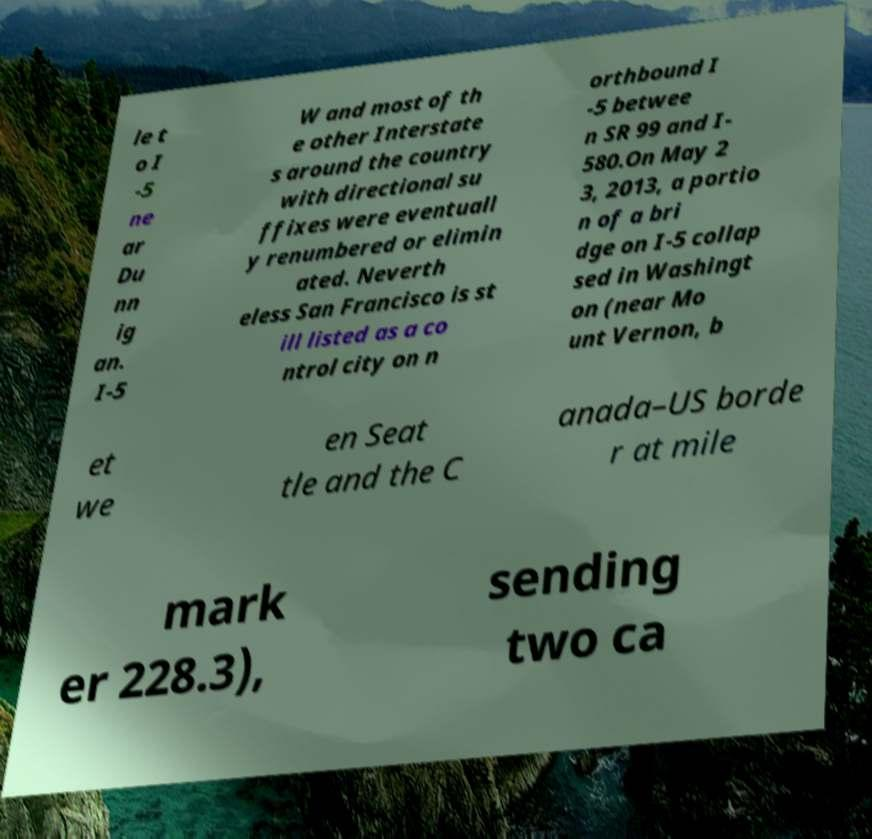There's text embedded in this image that I need extracted. Can you transcribe it verbatim? le t o I -5 ne ar Du nn ig an. I-5 W and most of th e other Interstate s around the country with directional su ffixes were eventuall y renumbered or elimin ated. Neverth eless San Francisco is st ill listed as a co ntrol city on n orthbound I -5 betwee n SR 99 and I- 580.On May 2 3, 2013, a portio n of a bri dge on I-5 collap sed in Washingt on (near Mo unt Vernon, b et we en Seat tle and the C anada–US borde r at mile mark er 228.3), sending two ca 